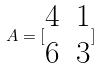<formula> <loc_0><loc_0><loc_500><loc_500>A = [ \begin{matrix} 4 & 1 \\ 6 & 3 \end{matrix} ]</formula> 